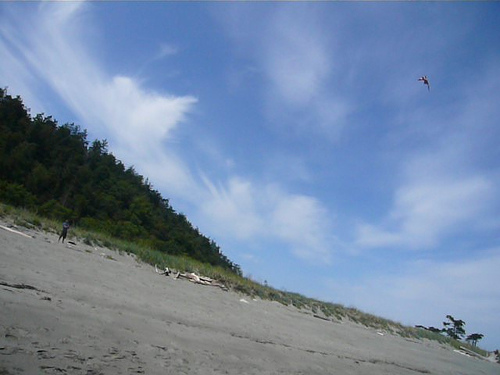<image>Who is holding the camera? It is unknown who is holding the camera. Who is holding the camera? It is ambiguous who is holding the camera. It can be seen that the camera is held by 'friend', 'man', 'person', 'unknown', 'photographer', 'human', 'woman', or 'cameraman'. 